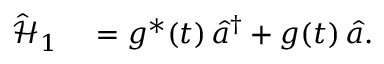<formula> <loc_0><loc_0><loc_500><loc_500>\begin{array} { r l } { \hat { \mathcal { H } } _ { 1 } } & = g ^ { * } ( t ) \, \hat { a } ^ { \dagger } + g ( t ) \, \hat { a } . } \end{array}</formula> 